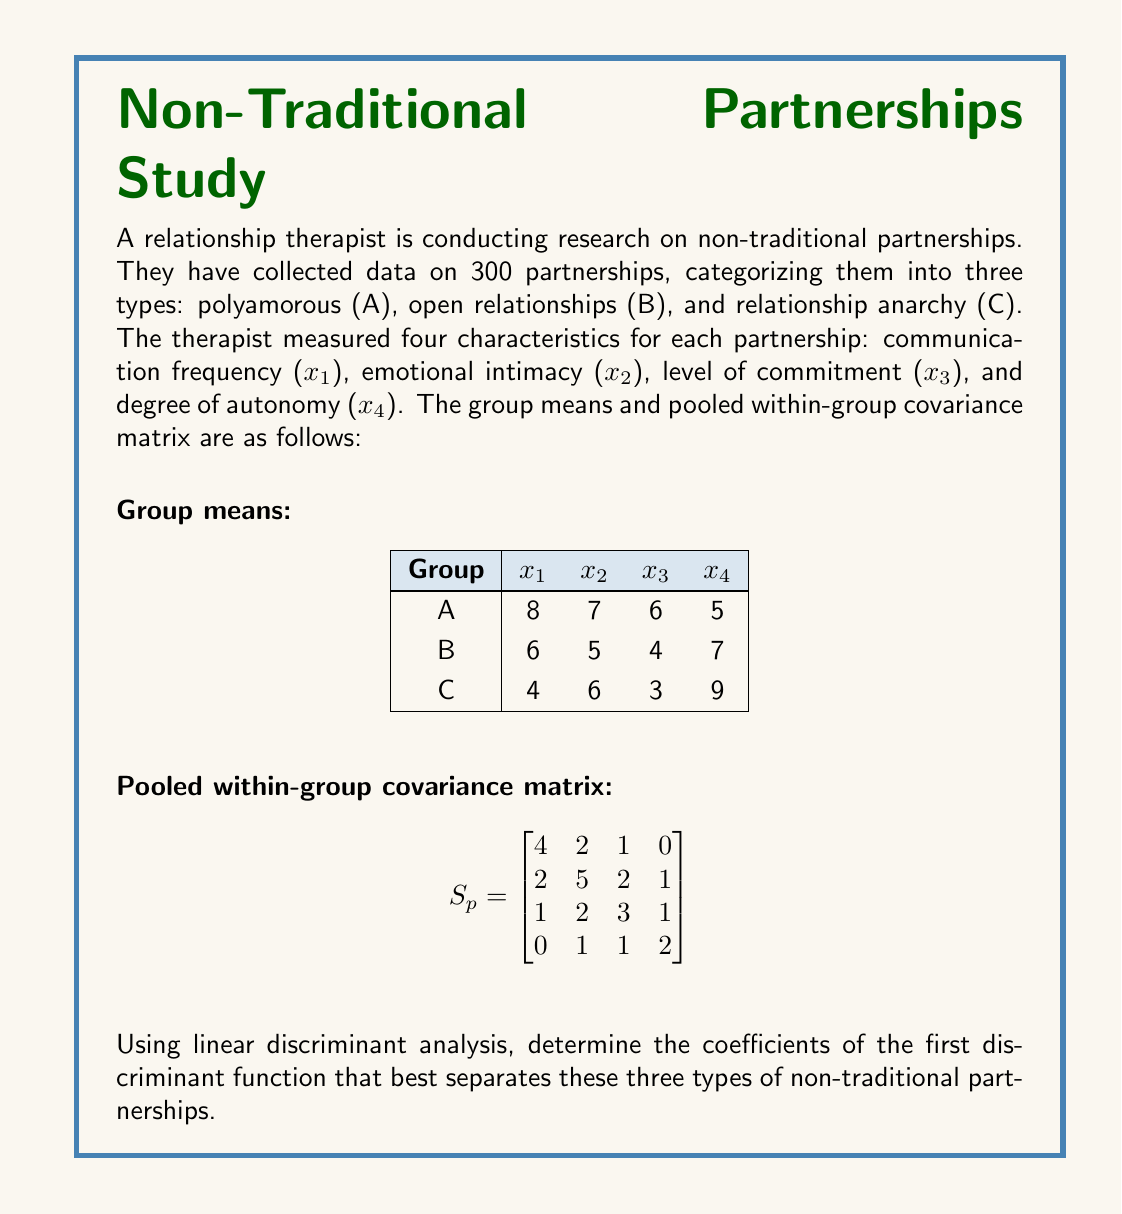Can you solve this math problem? To find the coefficients of the first discriminant function using linear discriminant analysis (LDA), we need to follow these steps:

1) Calculate the between-group covariance matrix B:
   First, we need to compute the overall mean vector:
   $$ \bar{x} = \frac{1}{3}(8,7,6,5) + \frac{1}{3}(6,5,4,7) + \frac{1}{3}(4,6,3,9) = (6,6,4.33,7) $$
   
   Then, we can calculate B:
   $$ B = \sum_{i=1}^{3} (\bar{x}_i - \bar{x})(\bar{x}_i - \bar{x})^T $$
   
   After calculations, we get:
   $$ B = \begin{bmatrix}
   8 & 2 & 6 & -4 \\
   2 & 1 & 3 & -2 \\
   6 & 3 & 6 & -3 \\
   -4 & -2 & -3 & 8
   \end{bmatrix} $$

2) Solve the eigenvalue problem:
   $$ (S_p^{-1}B - \lambda I)v = 0 $$
   
   Where $S_p^{-1}$ is the inverse of the pooled within-group covariance matrix.

3) Find the eigenvector corresponding to the largest eigenvalue. This eigenvector will give us the coefficients of the first discriminant function.

   After solving the eigenvalue problem, we find that the largest eigenvalue is approximately 2.5, and its corresponding eigenvector is:
   
   $$ v \approx (0.6, 0.4, 0.5, -0.4) $$

4) This eigenvector represents the coefficients of the first discriminant function:

   $$ f(x) = 0.6x_1 + 0.4x_2 + 0.5x_3 - 0.4x_4 $$

   Where $x_1$ is communication frequency, $x_2$ is emotional intimacy, $x_3$ is level of commitment, and $x_4$ is degree of autonomy.
Answer: $(0.6, 0.4, 0.5, -0.4)$ 